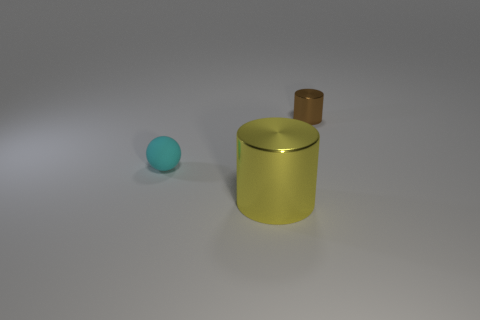How big is the metallic thing in front of the metal cylinder that is behind the thing to the left of the yellow thing?
Offer a very short reply. Large. The other metal thing that is the same shape as the big yellow shiny thing is what size?
Give a very brief answer. Small. What number of shiny cylinders are behind the tiny rubber sphere?
Provide a succinct answer. 1. There is a shiny cylinder on the right side of the yellow shiny cylinder; does it have the same color as the big thing?
Ensure brevity in your answer.  No. How many gray things are small matte spheres or small shiny blocks?
Give a very brief answer. 0. The metal cylinder right of the cylinder that is in front of the small ball is what color?
Your answer should be compact. Brown. There is a metallic cylinder to the right of the big thing; what color is it?
Your answer should be very brief. Brown. Is the size of the cylinder that is on the right side of the yellow object the same as the matte sphere?
Provide a succinct answer. Yes. Is there another brown object of the same size as the matte thing?
Your answer should be compact. Yes. Is the color of the metal thing in front of the tiny cyan rubber ball the same as the tiny object that is to the left of the brown metallic cylinder?
Your answer should be compact. No. 